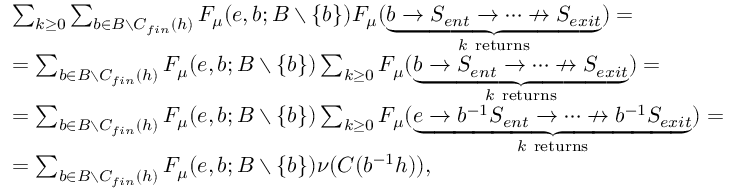<formula> <loc_0><loc_0><loc_500><loc_500>\begin{array} { r l } & { \sum _ { k \geq 0 } \sum _ { b \in B \ C _ { f i n } ( h ) } F _ { \mu } ( e , b ; B \ \{ b \} ) F _ { \mu } ( \underbrace { b \rightarrow S _ { e n t } \rightarrow \dots \nrightarrow S _ { e x i t } } _ { k r e t u r n s } ) = } \\ & { = \sum _ { b \in B \ C _ { f i n } ( h ) } F _ { \mu } ( e , b ; B \ \{ b \} ) \sum _ { k \geq 0 } F _ { \mu } ( \underbrace { b \rightarrow S _ { e n t } \rightarrow \dots \nrightarrow S _ { e x i t } } _ { k r e t u r n s } ) = } \\ & { = \sum _ { b \in B \ C _ { f i n } ( h ) } F _ { \mu } ( e , b ; B \ \{ b \} ) \sum _ { k \geq 0 } F _ { \mu } ( \underbrace { e \rightarrow b ^ { - 1 } S _ { e n t } \rightarrow \dots \nrightarrow b ^ { - 1 } S _ { e x i t } } _ { k r e t u r n s } ) = } \\ & { = \sum _ { b \in B \ C _ { f i n } ( h ) } F _ { \mu } ( e , b ; B \ \{ b \} ) \nu ( C ( b ^ { - 1 } h ) ) , } \end{array}</formula> 